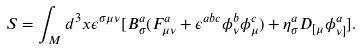Convert formula to latex. <formula><loc_0><loc_0><loc_500><loc_500>S = \int _ { M } d ^ { 3 } x \epsilon ^ { \sigma \mu \nu } [ B _ { \sigma } ^ { a } ( F _ { \mu \nu } ^ { a } + \epsilon ^ { a b c } \phi _ { \nu } ^ { b } \phi _ { \mu } ^ { c } ) + \eta _ { \sigma } ^ { a } D _ { [ \mu } \phi _ { \nu ] } ^ { a } ] .</formula> 